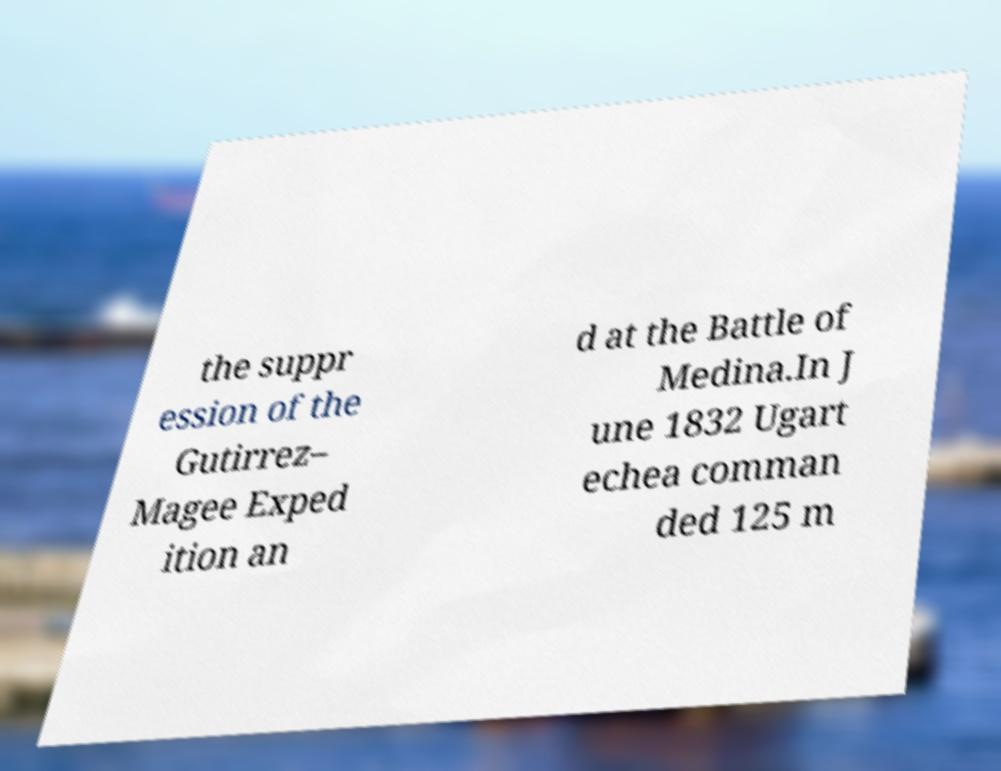Can you accurately transcribe the text from the provided image for me? the suppr ession of the Gutirrez– Magee Exped ition an d at the Battle of Medina.In J une 1832 Ugart echea comman ded 125 m 